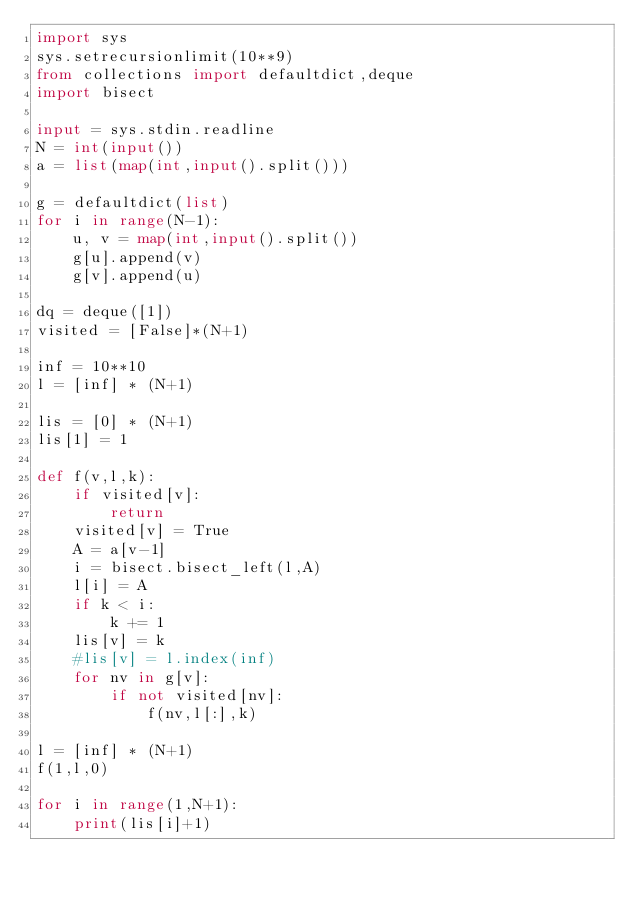<code> <loc_0><loc_0><loc_500><loc_500><_Python_>import sys
sys.setrecursionlimit(10**9)
from collections import defaultdict,deque
import bisect

input = sys.stdin.readline
N = int(input())
a = list(map(int,input().split()))

g = defaultdict(list)
for i in range(N-1):
    u, v = map(int,input().split())
    g[u].append(v)
    g[v].append(u)

dq = deque([1])
visited = [False]*(N+1)

inf = 10**10
l = [inf] * (N+1)

lis = [0] * (N+1)
lis[1] = 1

def f(v,l,k):
    if visited[v]:
        return
    visited[v] = True
    A = a[v-1]
    i = bisect.bisect_left(l,A)
    l[i] = A 
    if k < i:
        k += 1
    lis[v] = k
    #lis[v] = l.index(inf)
    for nv in g[v]:
        if not visited[nv]:
            f(nv,l[:],k)

l = [inf] * (N+1)
f(1,l,0)

for i in range(1,N+1):
    print(lis[i]+1)





</code> 